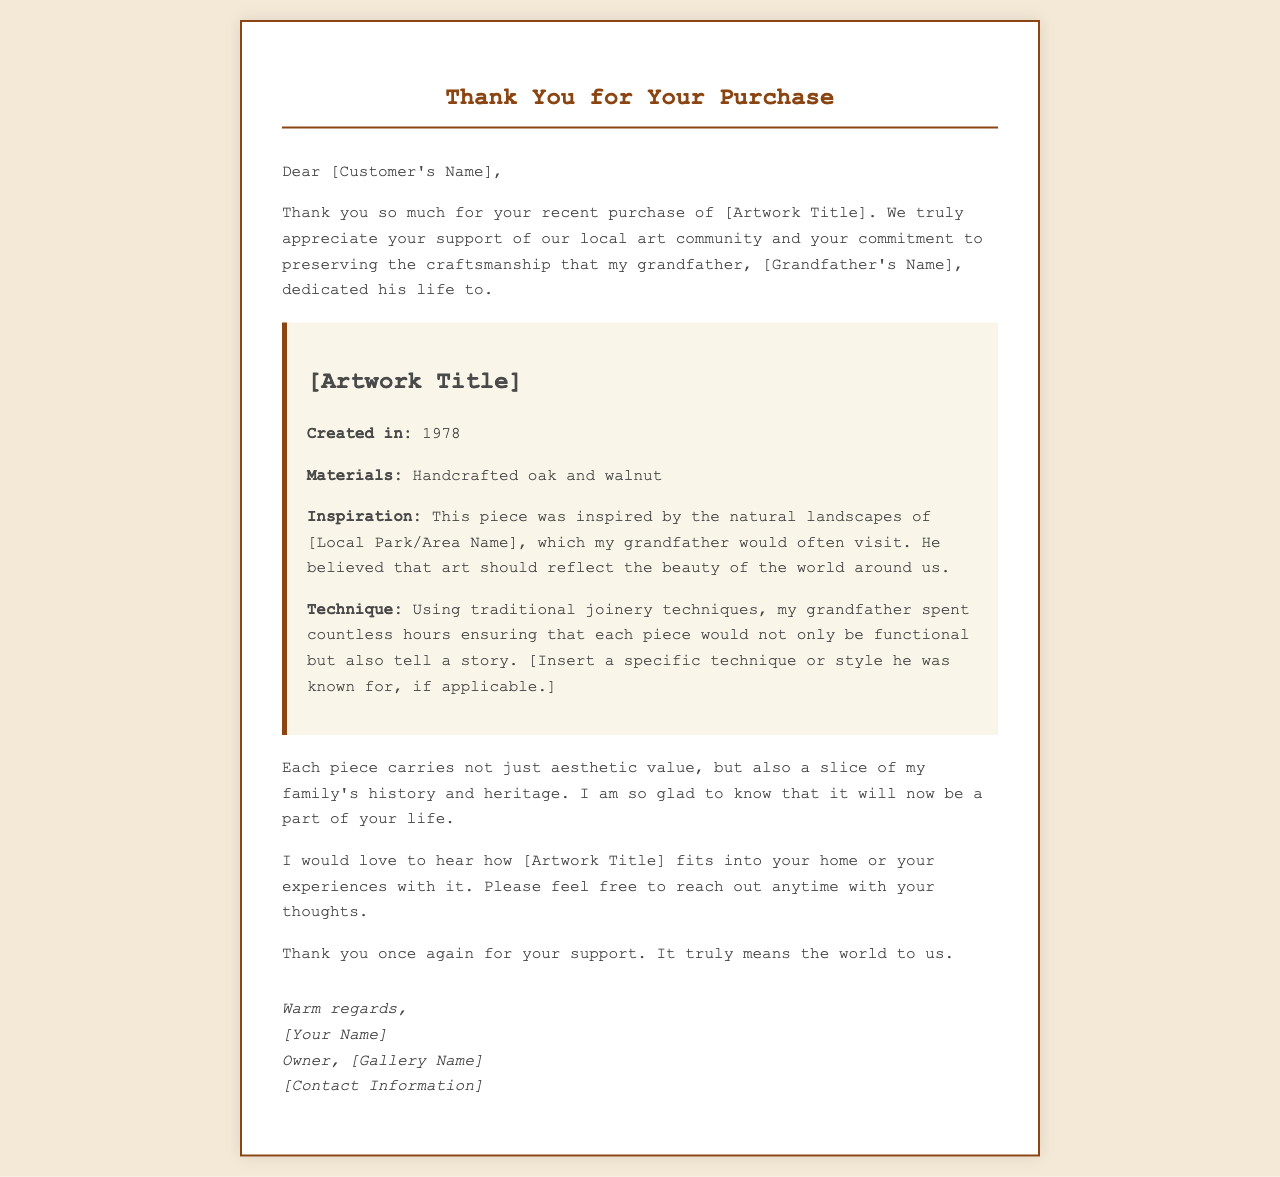What is the title of the artwork purchased? The title is mentioned in the opening appreciation of the letter after "your recent purchase of."
Answer: [Artwork Title] Who is the grandfather of the gallery owner? The letter expresses gratitude for the craftsmanship dedicated by the grandfather, whose name is stated.
Answer: [Grandfather's Name] What year was the artwork created? The creation year of the artwork is stated in the details section of the letter.
Answer: 1978 What materials are used in the artwork? The materials used in the artwork are listed in the artwork details section.
Answer: Handcrafted oak and walnut What inspired the creation of this piece? The inspiration for the artwork is mentioned as relating to a specific local area.
Answer: [Local Park/Area Name] What technique did the grandfather use for the artwork? A specific type of technique or style used by the grandfather is indicated in the letter.
Answer: [Insert a specific technique or style he was known for, if applicable.] What is the main message in the letter regarding the artwork's value? The letter indicates that the artwork carries aesthetic value and a deeper family connection.
Answer: A slice of my family's history and heritage How does the gallery owner invite customer feedback? The owner expresses a desire to hear back from the customer regarding their experience with the artwork.
Answer: Please feel free to reach out anytime with your thoughts What does the gallery owner express at the end of the letter? The closing remarks reflect gratitude and appreciation for the customer's support.
Answer: It truly means the world to us 